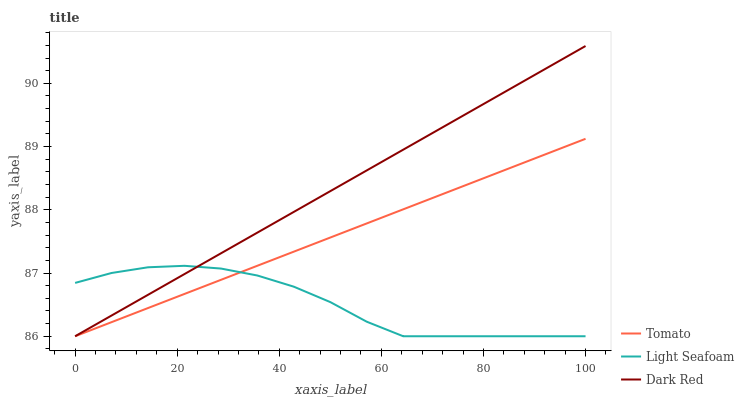Does Light Seafoam have the minimum area under the curve?
Answer yes or no. Yes. Does Dark Red have the maximum area under the curve?
Answer yes or no. Yes. Does Dark Red have the minimum area under the curve?
Answer yes or no. No. Does Light Seafoam have the maximum area under the curve?
Answer yes or no. No. Is Dark Red the smoothest?
Answer yes or no. Yes. Is Light Seafoam the roughest?
Answer yes or no. Yes. Is Light Seafoam the smoothest?
Answer yes or no. No. Is Dark Red the roughest?
Answer yes or no. No. Does Tomato have the lowest value?
Answer yes or no. Yes. Does Dark Red have the highest value?
Answer yes or no. Yes. Does Light Seafoam have the highest value?
Answer yes or no. No. Does Tomato intersect Dark Red?
Answer yes or no. Yes. Is Tomato less than Dark Red?
Answer yes or no. No. Is Tomato greater than Dark Red?
Answer yes or no. No. 